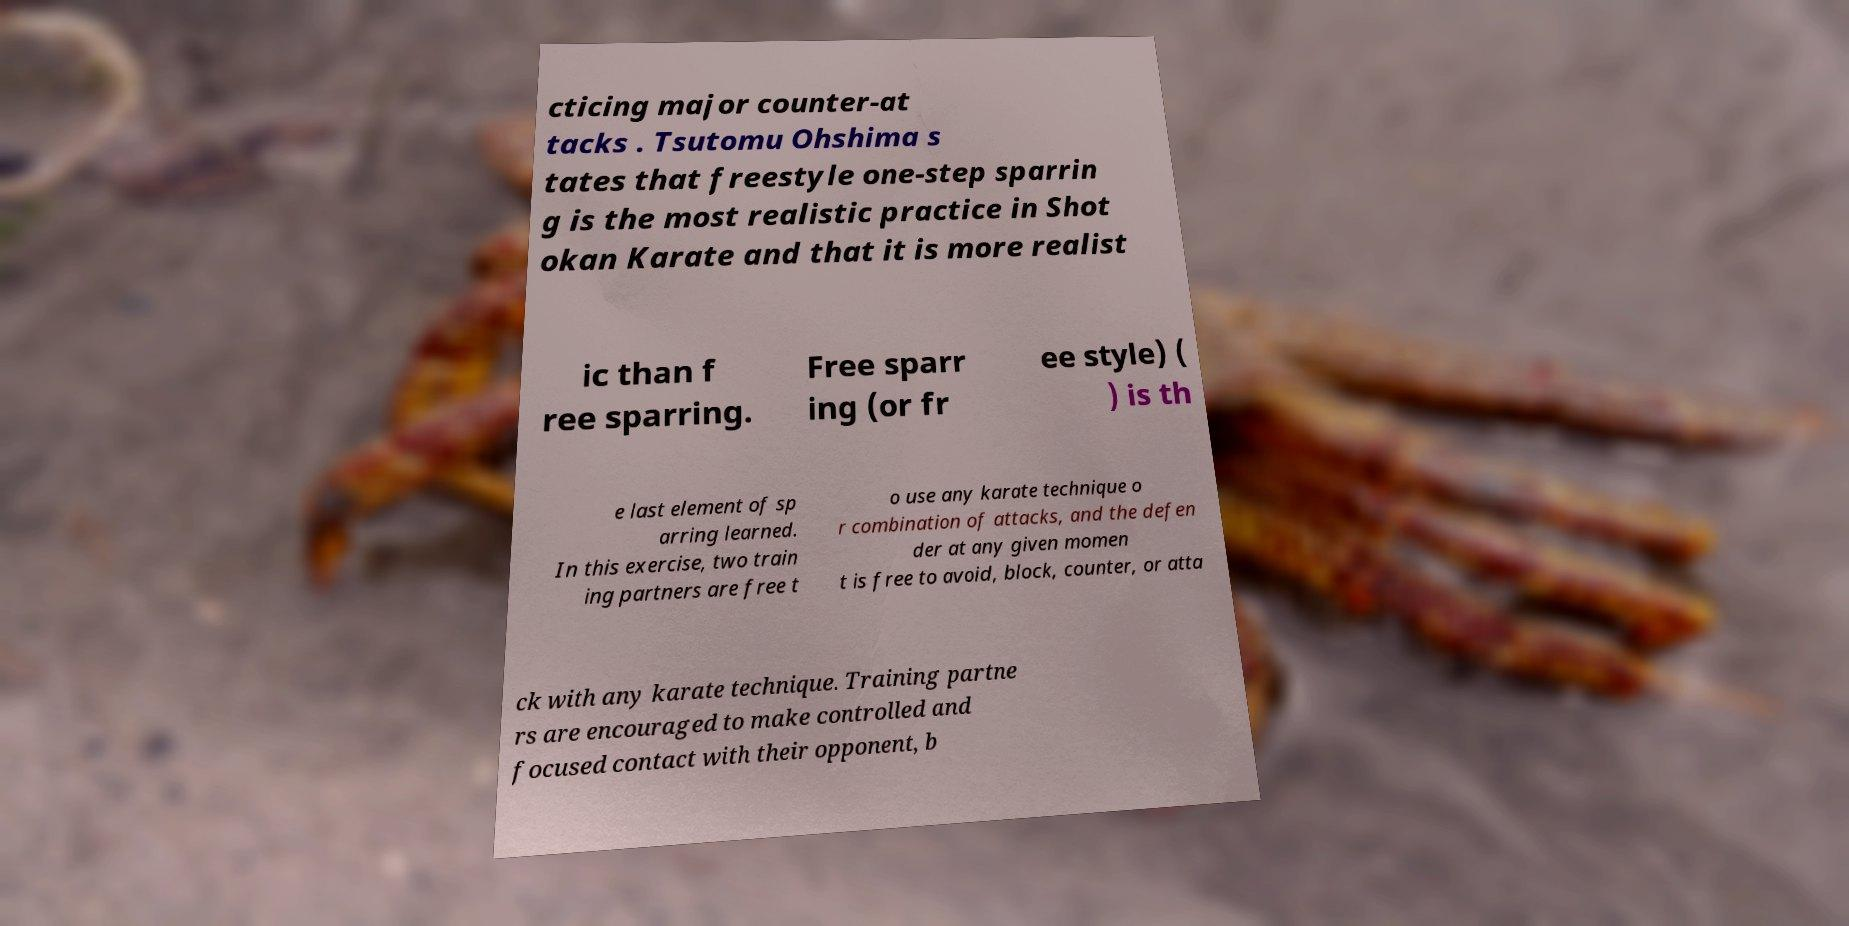Could you assist in decoding the text presented in this image and type it out clearly? cticing major counter-at tacks . Tsutomu Ohshima s tates that freestyle one-step sparrin g is the most realistic practice in Shot okan Karate and that it is more realist ic than f ree sparring. Free sparr ing (or fr ee style) ( ) is th e last element of sp arring learned. In this exercise, two train ing partners are free t o use any karate technique o r combination of attacks, and the defen der at any given momen t is free to avoid, block, counter, or atta ck with any karate technique. Training partne rs are encouraged to make controlled and focused contact with their opponent, b 